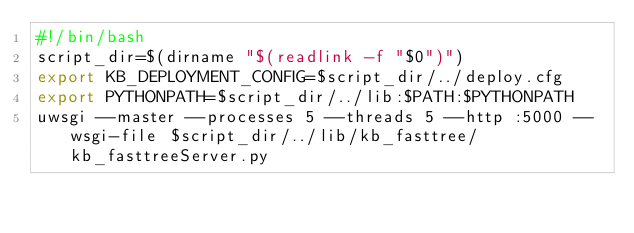<code> <loc_0><loc_0><loc_500><loc_500><_Bash_>#!/bin/bash
script_dir=$(dirname "$(readlink -f "$0")")
export KB_DEPLOYMENT_CONFIG=$script_dir/../deploy.cfg
export PYTHONPATH=$script_dir/../lib:$PATH:$PYTHONPATH
uwsgi --master --processes 5 --threads 5 --http :5000 --wsgi-file $script_dir/../lib/kb_fasttree/kb_fasttreeServer.py
</code> 